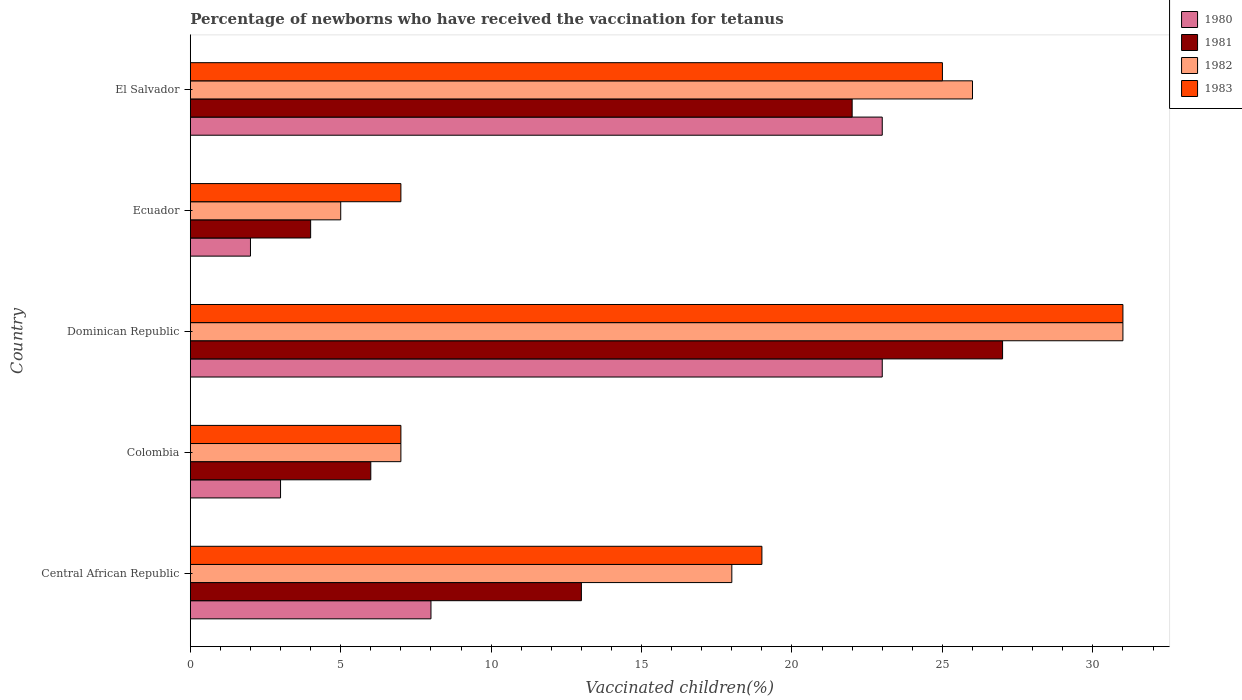How many different coloured bars are there?
Ensure brevity in your answer.  4. Are the number of bars per tick equal to the number of legend labels?
Keep it short and to the point. Yes. Are the number of bars on each tick of the Y-axis equal?
Keep it short and to the point. Yes. In how many cases, is the number of bars for a given country not equal to the number of legend labels?
Give a very brief answer. 0. What is the percentage of vaccinated children in 1982 in Dominican Republic?
Your answer should be compact. 31. Across all countries, what is the maximum percentage of vaccinated children in 1982?
Give a very brief answer. 31. Across all countries, what is the minimum percentage of vaccinated children in 1980?
Keep it short and to the point. 2. In which country was the percentage of vaccinated children in 1983 maximum?
Provide a succinct answer. Dominican Republic. In which country was the percentage of vaccinated children in 1980 minimum?
Keep it short and to the point. Ecuador. What is the total percentage of vaccinated children in 1980 in the graph?
Your answer should be very brief. 59. What is the difference between the percentage of vaccinated children in 1983 in Dominican Republic and the percentage of vaccinated children in 1980 in El Salvador?
Offer a terse response. 8. What is the difference between the highest and the second highest percentage of vaccinated children in 1981?
Provide a short and direct response. 5. Is it the case that in every country, the sum of the percentage of vaccinated children in 1981 and percentage of vaccinated children in 1983 is greater than the sum of percentage of vaccinated children in 1982 and percentage of vaccinated children in 1980?
Your response must be concise. Yes. What does the 2nd bar from the bottom in El Salvador represents?
Offer a very short reply. 1981. Is it the case that in every country, the sum of the percentage of vaccinated children in 1980 and percentage of vaccinated children in 1981 is greater than the percentage of vaccinated children in 1982?
Provide a succinct answer. Yes. How many countries are there in the graph?
Offer a very short reply. 5. Are the values on the major ticks of X-axis written in scientific E-notation?
Keep it short and to the point. No. Does the graph contain any zero values?
Ensure brevity in your answer.  No. Does the graph contain grids?
Your response must be concise. No. Where does the legend appear in the graph?
Make the answer very short. Top right. How many legend labels are there?
Offer a very short reply. 4. What is the title of the graph?
Offer a very short reply. Percentage of newborns who have received the vaccination for tetanus. Does "2001" appear as one of the legend labels in the graph?
Provide a short and direct response. No. What is the label or title of the X-axis?
Your response must be concise. Vaccinated children(%). What is the label or title of the Y-axis?
Your answer should be compact. Country. What is the Vaccinated children(%) of 1980 in Central African Republic?
Ensure brevity in your answer.  8. What is the Vaccinated children(%) of 1982 in Central African Republic?
Make the answer very short. 18. What is the Vaccinated children(%) of 1981 in Colombia?
Provide a succinct answer. 6. What is the Vaccinated children(%) in 1980 in Dominican Republic?
Your answer should be very brief. 23. What is the Vaccinated children(%) of 1981 in Dominican Republic?
Your answer should be compact. 27. What is the Vaccinated children(%) in 1982 in Dominican Republic?
Give a very brief answer. 31. What is the Vaccinated children(%) in 1983 in Dominican Republic?
Your answer should be compact. 31. What is the Vaccinated children(%) in 1981 in Ecuador?
Your response must be concise. 4. What is the Vaccinated children(%) in 1982 in Ecuador?
Your answer should be very brief. 5. What is the Vaccinated children(%) of 1983 in Ecuador?
Offer a terse response. 7. What is the Vaccinated children(%) in 1980 in El Salvador?
Offer a terse response. 23. Across all countries, what is the maximum Vaccinated children(%) in 1983?
Your answer should be very brief. 31. Across all countries, what is the minimum Vaccinated children(%) in 1981?
Offer a very short reply. 4. Across all countries, what is the minimum Vaccinated children(%) in 1982?
Provide a short and direct response. 5. What is the total Vaccinated children(%) in 1981 in the graph?
Your response must be concise. 72. What is the total Vaccinated children(%) of 1982 in the graph?
Provide a short and direct response. 87. What is the total Vaccinated children(%) in 1983 in the graph?
Provide a succinct answer. 89. What is the difference between the Vaccinated children(%) of 1980 in Central African Republic and that in Colombia?
Keep it short and to the point. 5. What is the difference between the Vaccinated children(%) of 1983 in Central African Republic and that in Colombia?
Provide a succinct answer. 12. What is the difference between the Vaccinated children(%) in 1981 in Central African Republic and that in Dominican Republic?
Offer a very short reply. -14. What is the difference between the Vaccinated children(%) of 1983 in Central African Republic and that in Dominican Republic?
Provide a short and direct response. -12. What is the difference between the Vaccinated children(%) of 1980 in Central African Republic and that in Ecuador?
Ensure brevity in your answer.  6. What is the difference between the Vaccinated children(%) in 1981 in Central African Republic and that in Ecuador?
Your answer should be compact. 9. What is the difference between the Vaccinated children(%) in 1983 in Central African Republic and that in Ecuador?
Your answer should be compact. 12. What is the difference between the Vaccinated children(%) of 1980 in Central African Republic and that in El Salvador?
Your answer should be very brief. -15. What is the difference between the Vaccinated children(%) of 1983 in Central African Republic and that in El Salvador?
Ensure brevity in your answer.  -6. What is the difference between the Vaccinated children(%) in 1980 in Colombia and that in Dominican Republic?
Offer a very short reply. -20. What is the difference between the Vaccinated children(%) in 1981 in Colombia and that in Dominican Republic?
Provide a short and direct response. -21. What is the difference between the Vaccinated children(%) in 1980 in Colombia and that in Ecuador?
Offer a terse response. 1. What is the difference between the Vaccinated children(%) of 1981 in Colombia and that in Ecuador?
Give a very brief answer. 2. What is the difference between the Vaccinated children(%) in 1982 in Colombia and that in Ecuador?
Provide a short and direct response. 2. What is the difference between the Vaccinated children(%) of 1983 in Colombia and that in Ecuador?
Offer a very short reply. 0. What is the difference between the Vaccinated children(%) in 1980 in Colombia and that in El Salvador?
Make the answer very short. -20. What is the difference between the Vaccinated children(%) in 1981 in Colombia and that in El Salvador?
Your response must be concise. -16. What is the difference between the Vaccinated children(%) of 1982 in Colombia and that in El Salvador?
Offer a terse response. -19. What is the difference between the Vaccinated children(%) of 1983 in Colombia and that in El Salvador?
Your response must be concise. -18. What is the difference between the Vaccinated children(%) of 1980 in Dominican Republic and that in Ecuador?
Keep it short and to the point. 21. What is the difference between the Vaccinated children(%) in 1981 in Dominican Republic and that in Ecuador?
Offer a very short reply. 23. What is the difference between the Vaccinated children(%) of 1983 in Dominican Republic and that in Ecuador?
Your answer should be very brief. 24. What is the difference between the Vaccinated children(%) of 1981 in Dominican Republic and that in El Salvador?
Provide a short and direct response. 5. What is the difference between the Vaccinated children(%) in 1982 in Dominican Republic and that in El Salvador?
Your answer should be very brief. 5. What is the difference between the Vaccinated children(%) in 1981 in Ecuador and that in El Salvador?
Your answer should be very brief. -18. What is the difference between the Vaccinated children(%) of 1982 in Ecuador and that in El Salvador?
Make the answer very short. -21. What is the difference between the Vaccinated children(%) in 1983 in Ecuador and that in El Salvador?
Your answer should be compact. -18. What is the difference between the Vaccinated children(%) of 1980 in Central African Republic and the Vaccinated children(%) of 1981 in Colombia?
Make the answer very short. 2. What is the difference between the Vaccinated children(%) of 1980 in Central African Republic and the Vaccinated children(%) of 1982 in Dominican Republic?
Provide a short and direct response. -23. What is the difference between the Vaccinated children(%) of 1982 in Central African Republic and the Vaccinated children(%) of 1983 in Dominican Republic?
Your answer should be compact. -13. What is the difference between the Vaccinated children(%) of 1980 in Central African Republic and the Vaccinated children(%) of 1981 in Ecuador?
Offer a very short reply. 4. What is the difference between the Vaccinated children(%) in 1981 in Central African Republic and the Vaccinated children(%) in 1982 in Ecuador?
Offer a very short reply. 8. What is the difference between the Vaccinated children(%) of 1981 in Central African Republic and the Vaccinated children(%) of 1983 in Ecuador?
Ensure brevity in your answer.  6. What is the difference between the Vaccinated children(%) in 1980 in Central African Republic and the Vaccinated children(%) in 1981 in El Salvador?
Provide a succinct answer. -14. What is the difference between the Vaccinated children(%) of 1980 in Central African Republic and the Vaccinated children(%) of 1982 in El Salvador?
Keep it short and to the point. -18. What is the difference between the Vaccinated children(%) of 1980 in Central African Republic and the Vaccinated children(%) of 1983 in El Salvador?
Ensure brevity in your answer.  -17. What is the difference between the Vaccinated children(%) of 1981 in Central African Republic and the Vaccinated children(%) of 1982 in El Salvador?
Offer a very short reply. -13. What is the difference between the Vaccinated children(%) of 1981 in Colombia and the Vaccinated children(%) of 1982 in Dominican Republic?
Your answer should be very brief. -25. What is the difference between the Vaccinated children(%) in 1981 in Colombia and the Vaccinated children(%) in 1983 in Dominican Republic?
Provide a succinct answer. -25. What is the difference between the Vaccinated children(%) of 1981 in Colombia and the Vaccinated children(%) of 1982 in Ecuador?
Offer a very short reply. 1. What is the difference between the Vaccinated children(%) of 1981 in Colombia and the Vaccinated children(%) of 1983 in Ecuador?
Your answer should be compact. -1. What is the difference between the Vaccinated children(%) in 1981 in Colombia and the Vaccinated children(%) in 1983 in El Salvador?
Provide a succinct answer. -19. What is the difference between the Vaccinated children(%) in 1980 in Dominican Republic and the Vaccinated children(%) in 1981 in Ecuador?
Ensure brevity in your answer.  19. What is the difference between the Vaccinated children(%) in 1980 in Dominican Republic and the Vaccinated children(%) in 1982 in Ecuador?
Make the answer very short. 18. What is the difference between the Vaccinated children(%) in 1980 in Dominican Republic and the Vaccinated children(%) in 1983 in Ecuador?
Provide a short and direct response. 16. What is the difference between the Vaccinated children(%) of 1981 in Dominican Republic and the Vaccinated children(%) of 1983 in Ecuador?
Your answer should be compact. 20. What is the difference between the Vaccinated children(%) of 1982 in Dominican Republic and the Vaccinated children(%) of 1983 in Ecuador?
Provide a succinct answer. 24. What is the difference between the Vaccinated children(%) in 1981 in Dominican Republic and the Vaccinated children(%) in 1982 in El Salvador?
Offer a terse response. 1. What is the difference between the Vaccinated children(%) in 1980 in Ecuador and the Vaccinated children(%) in 1983 in El Salvador?
Ensure brevity in your answer.  -23. What is the difference between the Vaccinated children(%) in 1981 in Ecuador and the Vaccinated children(%) in 1982 in El Salvador?
Make the answer very short. -22. What is the difference between the Vaccinated children(%) of 1980 and Vaccinated children(%) of 1982 in Central African Republic?
Offer a terse response. -10. What is the difference between the Vaccinated children(%) of 1981 and Vaccinated children(%) of 1982 in Central African Republic?
Provide a short and direct response. -5. What is the difference between the Vaccinated children(%) in 1980 and Vaccinated children(%) in 1981 in Colombia?
Your response must be concise. -3. What is the difference between the Vaccinated children(%) of 1980 and Vaccinated children(%) of 1982 in Colombia?
Provide a succinct answer. -4. What is the difference between the Vaccinated children(%) in 1981 and Vaccinated children(%) in 1982 in Colombia?
Provide a succinct answer. -1. What is the difference between the Vaccinated children(%) of 1981 and Vaccinated children(%) of 1983 in Colombia?
Give a very brief answer. -1. What is the difference between the Vaccinated children(%) of 1981 and Vaccinated children(%) of 1983 in Ecuador?
Ensure brevity in your answer.  -3. What is the difference between the Vaccinated children(%) in 1982 and Vaccinated children(%) in 1983 in El Salvador?
Ensure brevity in your answer.  1. What is the ratio of the Vaccinated children(%) in 1980 in Central African Republic to that in Colombia?
Keep it short and to the point. 2.67. What is the ratio of the Vaccinated children(%) in 1981 in Central African Republic to that in Colombia?
Provide a succinct answer. 2.17. What is the ratio of the Vaccinated children(%) in 1982 in Central African Republic to that in Colombia?
Make the answer very short. 2.57. What is the ratio of the Vaccinated children(%) of 1983 in Central African Republic to that in Colombia?
Provide a succinct answer. 2.71. What is the ratio of the Vaccinated children(%) of 1980 in Central African Republic to that in Dominican Republic?
Your answer should be very brief. 0.35. What is the ratio of the Vaccinated children(%) of 1981 in Central African Republic to that in Dominican Republic?
Provide a short and direct response. 0.48. What is the ratio of the Vaccinated children(%) of 1982 in Central African Republic to that in Dominican Republic?
Give a very brief answer. 0.58. What is the ratio of the Vaccinated children(%) in 1983 in Central African Republic to that in Dominican Republic?
Your answer should be very brief. 0.61. What is the ratio of the Vaccinated children(%) in 1982 in Central African Republic to that in Ecuador?
Make the answer very short. 3.6. What is the ratio of the Vaccinated children(%) of 1983 in Central African Republic to that in Ecuador?
Your response must be concise. 2.71. What is the ratio of the Vaccinated children(%) in 1980 in Central African Republic to that in El Salvador?
Offer a terse response. 0.35. What is the ratio of the Vaccinated children(%) of 1981 in Central African Republic to that in El Salvador?
Offer a very short reply. 0.59. What is the ratio of the Vaccinated children(%) of 1982 in Central African Republic to that in El Salvador?
Give a very brief answer. 0.69. What is the ratio of the Vaccinated children(%) of 1983 in Central African Republic to that in El Salvador?
Keep it short and to the point. 0.76. What is the ratio of the Vaccinated children(%) in 1980 in Colombia to that in Dominican Republic?
Ensure brevity in your answer.  0.13. What is the ratio of the Vaccinated children(%) in 1981 in Colombia to that in Dominican Republic?
Offer a very short reply. 0.22. What is the ratio of the Vaccinated children(%) of 1982 in Colombia to that in Dominican Republic?
Your answer should be very brief. 0.23. What is the ratio of the Vaccinated children(%) in 1983 in Colombia to that in Dominican Republic?
Provide a short and direct response. 0.23. What is the ratio of the Vaccinated children(%) of 1980 in Colombia to that in Ecuador?
Your response must be concise. 1.5. What is the ratio of the Vaccinated children(%) of 1982 in Colombia to that in Ecuador?
Your answer should be compact. 1.4. What is the ratio of the Vaccinated children(%) in 1980 in Colombia to that in El Salvador?
Your response must be concise. 0.13. What is the ratio of the Vaccinated children(%) in 1981 in Colombia to that in El Salvador?
Give a very brief answer. 0.27. What is the ratio of the Vaccinated children(%) in 1982 in Colombia to that in El Salvador?
Offer a very short reply. 0.27. What is the ratio of the Vaccinated children(%) of 1983 in Colombia to that in El Salvador?
Keep it short and to the point. 0.28. What is the ratio of the Vaccinated children(%) of 1980 in Dominican Republic to that in Ecuador?
Your response must be concise. 11.5. What is the ratio of the Vaccinated children(%) in 1981 in Dominican Republic to that in Ecuador?
Your response must be concise. 6.75. What is the ratio of the Vaccinated children(%) in 1982 in Dominican Republic to that in Ecuador?
Make the answer very short. 6.2. What is the ratio of the Vaccinated children(%) of 1983 in Dominican Republic to that in Ecuador?
Provide a succinct answer. 4.43. What is the ratio of the Vaccinated children(%) of 1980 in Dominican Republic to that in El Salvador?
Ensure brevity in your answer.  1. What is the ratio of the Vaccinated children(%) in 1981 in Dominican Republic to that in El Salvador?
Offer a very short reply. 1.23. What is the ratio of the Vaccinated children(%) in 1982 in Dominican Republic to that in El Salvador?
Your answer should be very brief. 1.19. What is the ratio of the Vaccinated children(%) of 1983 in Dominican Republic to that in El Salvador?
Provide a succinct answer. 1.24. What is the ratio of the Vaccinated children(%) in 1980 in Ecuador to that in El Salvador?
Provide a short and direct response. 0.09. What is the ratio of the Vaccinated children(%) in 1981 in Ecuador to that in El Salvador?
Provide a succinct answer. 0.18. What is the ratio of the Vaccinated children(%) in 1982 in Ecuador to that in El Salvador?
Offer a very short reply. 0.19. What is the ratio of the Vaccinated children(%) in 1983 in Ecuador to that in El Salvador?
Ensure brevity in your answer.  0.28. What is the difference between the highest and the second highest Vaccinated children(%) of 1981?
Your response must be concise. 5. What is the difference between the highest and the second highest Vaccinated children(%) in 1983?
Your response must be concise. 6. What is the difference between the highest and the lowest Vaccinated children(%) in 1982?
Your answer should be very brief. 26. What is the difference between the highest and the lowest Vaccinated children(%) of 1983?
Your answer should be compact. 24. 